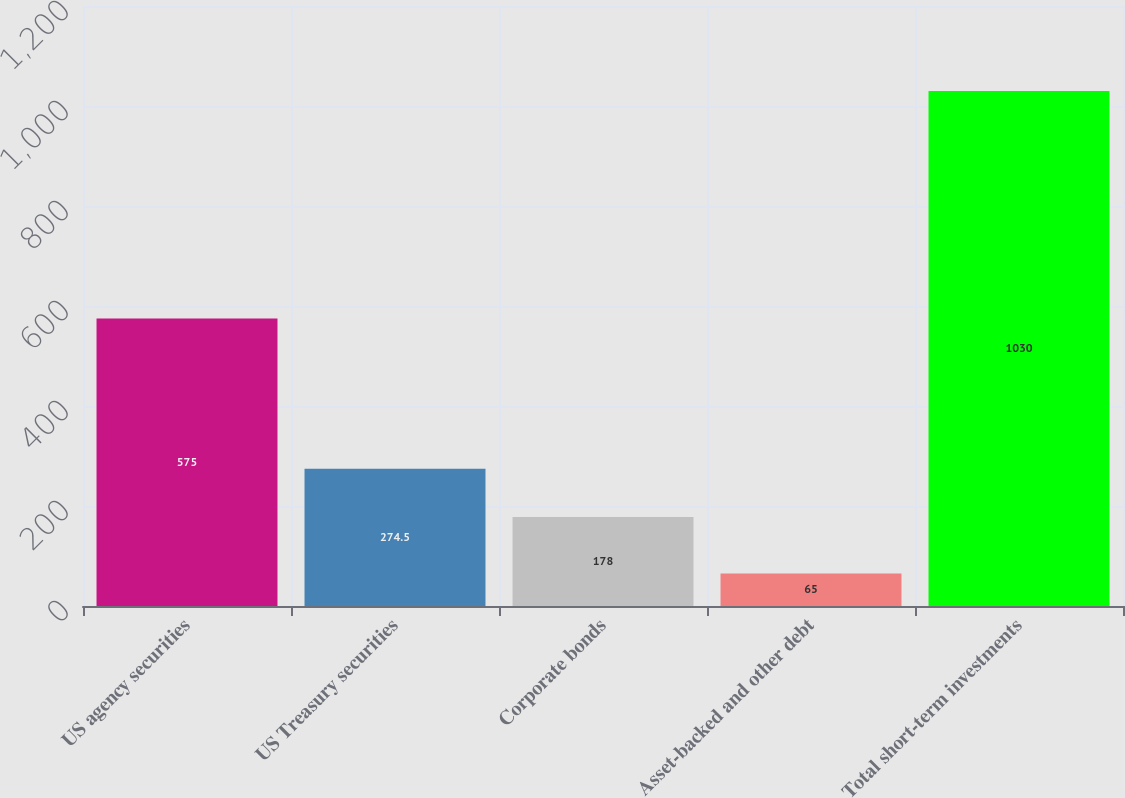Convert chart. <chart><loc_0><loc_0><loc_500><loc_500><bar_chart><fcel>US agency securities<fcel>US Treasury securities<fcel>Corporate bonds<fcel>Asset-backed and other debt<fcel>Total short-term investments<nl><fcel>575<fcel>274.5<fcel>178<fcel>65<fcel>1030<nl></chart> 